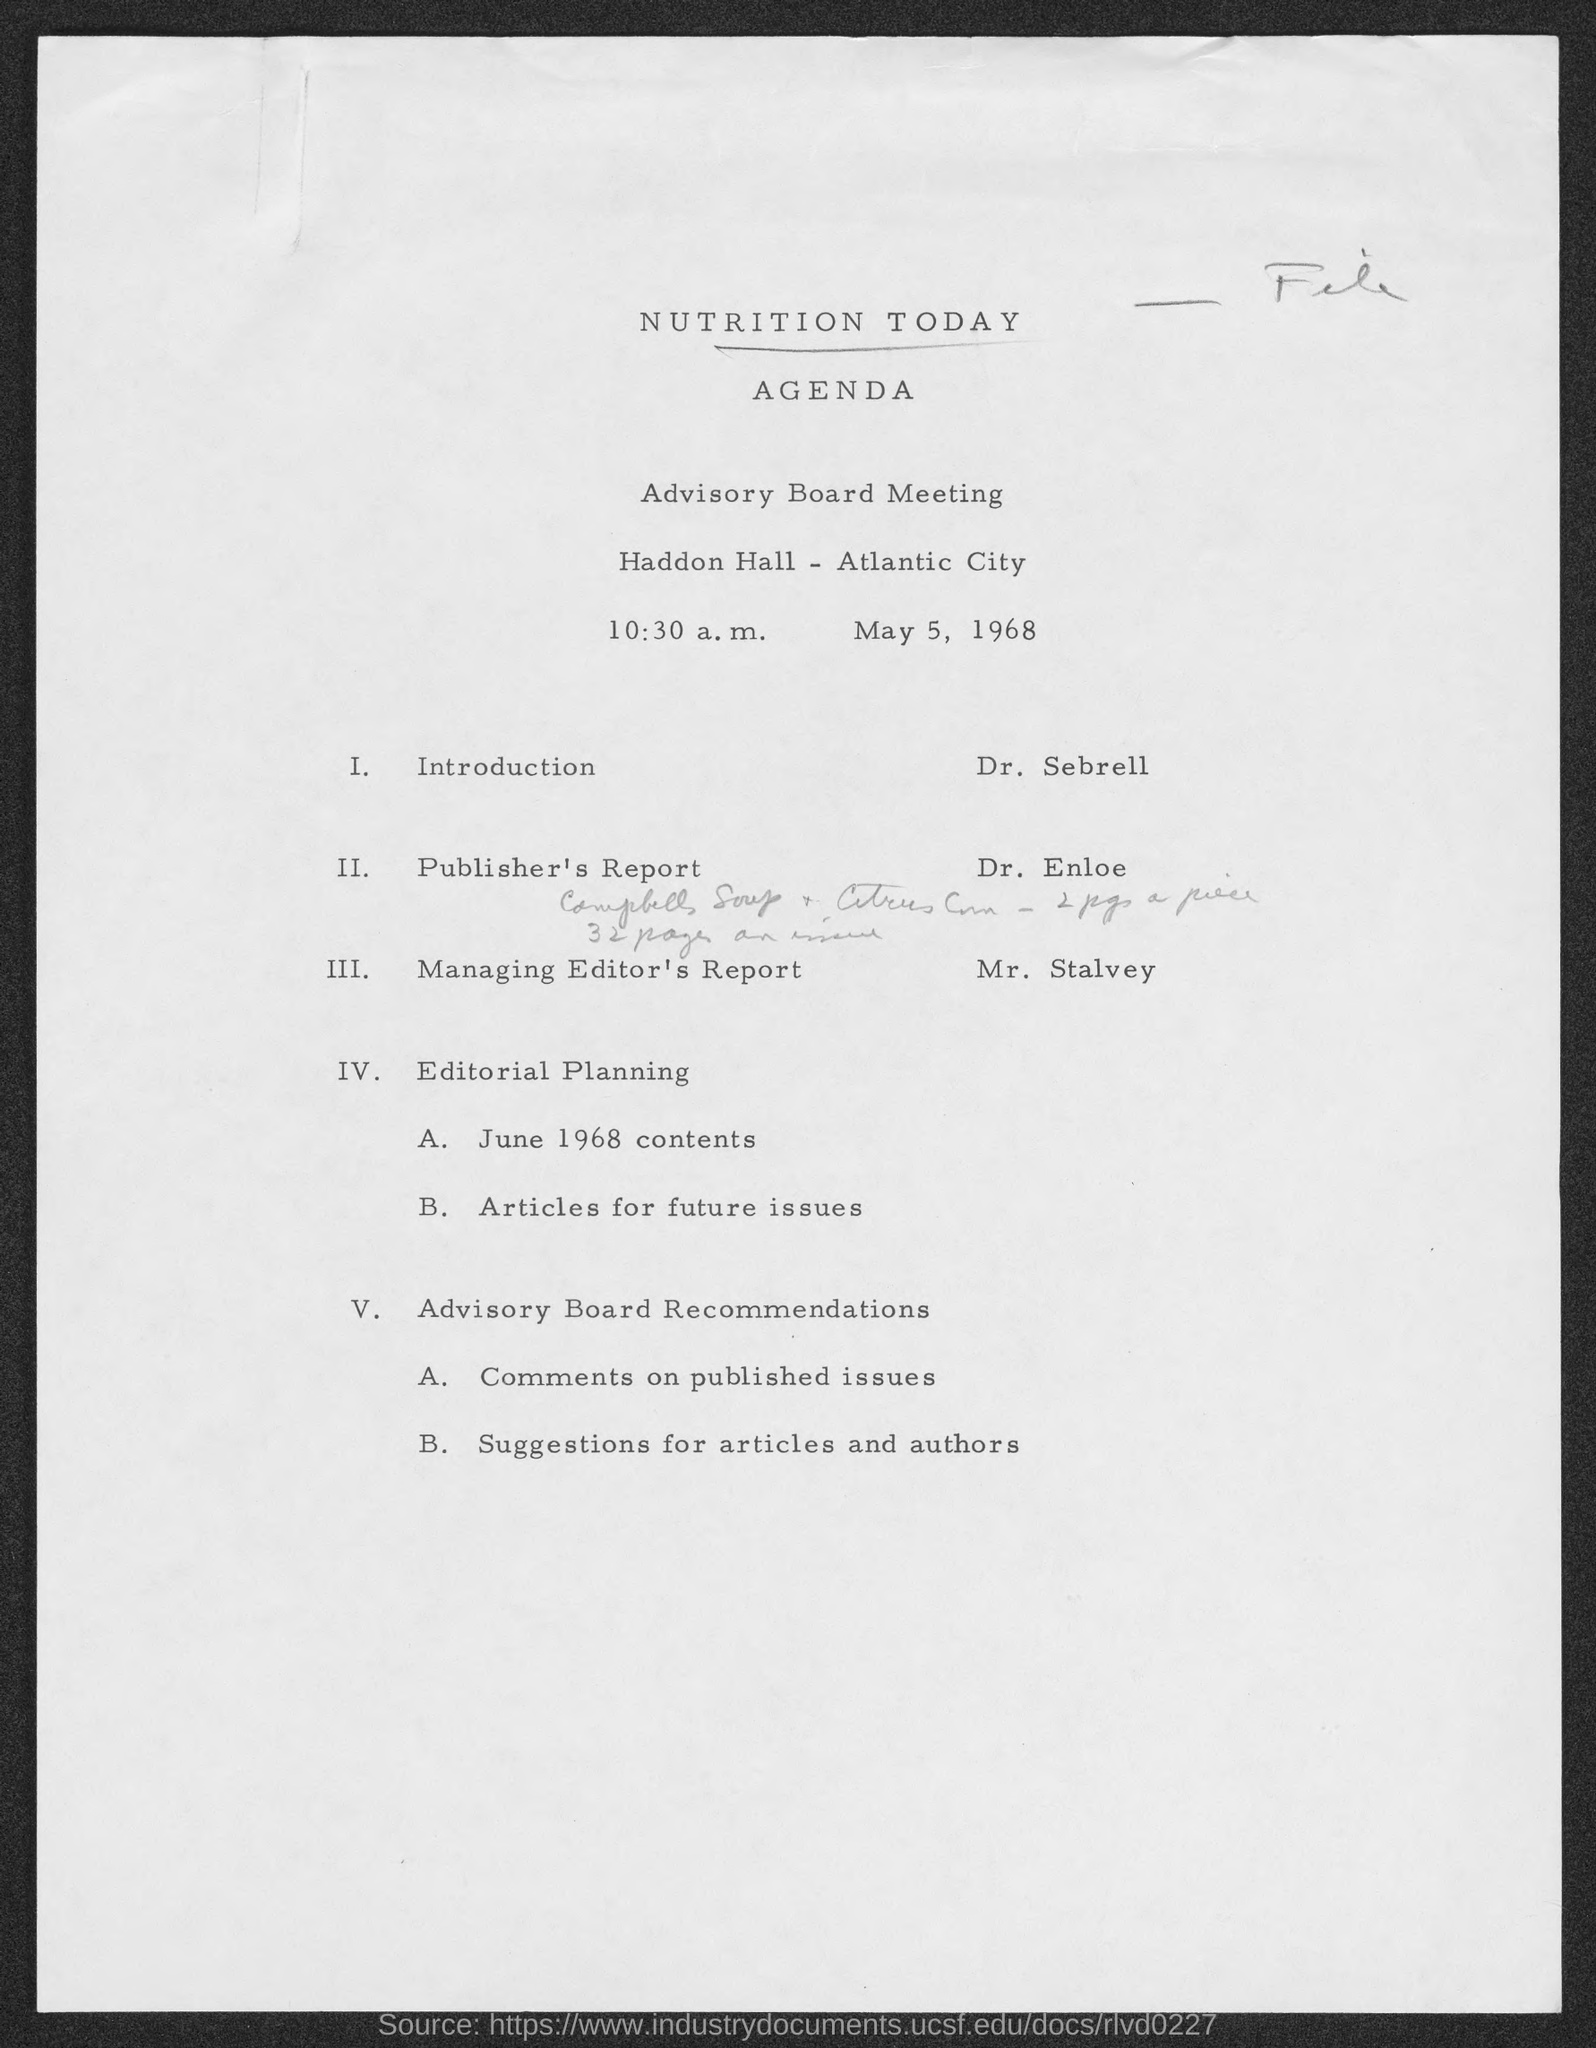At what time is the meeting?
Offer a terse response. 10:30 a.m. Who will give the introduction?
Make the answer very short. Dr. Sebrell. What is Mr. Stalvey's topic?
Ensure brevity in your answer.  Managing Editor's Report. 